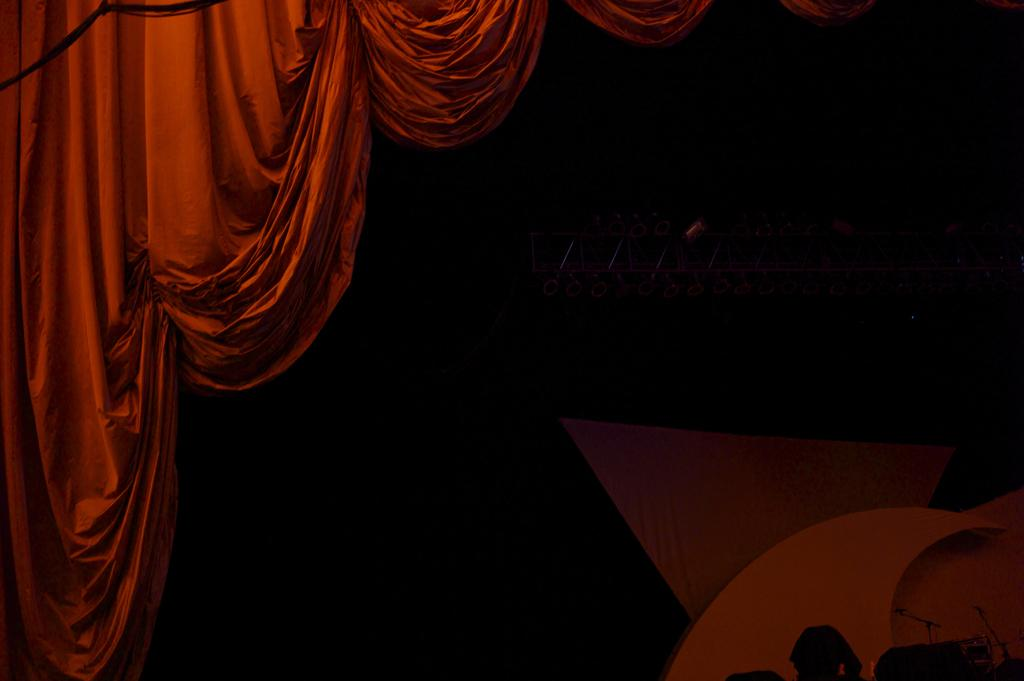What color is the curtain that is visible in the image? There is a red curtain in the image. What can be said about the background of the image? The background of the image is dark. What type of instrument is being played in the image? There is no instrument present in the image. Is there a ring visible on anyone's finger in the image? There is no ring visible on anyone's finger in the image. How many planes can be seen in the image? There are no planes present in the image. 